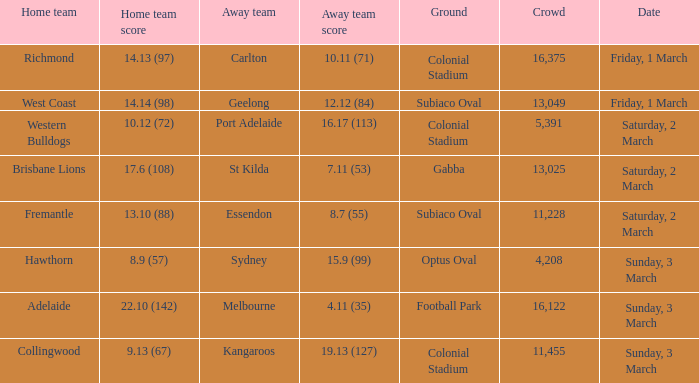At what time was geelong considered the away team? Friday, 1 March. 